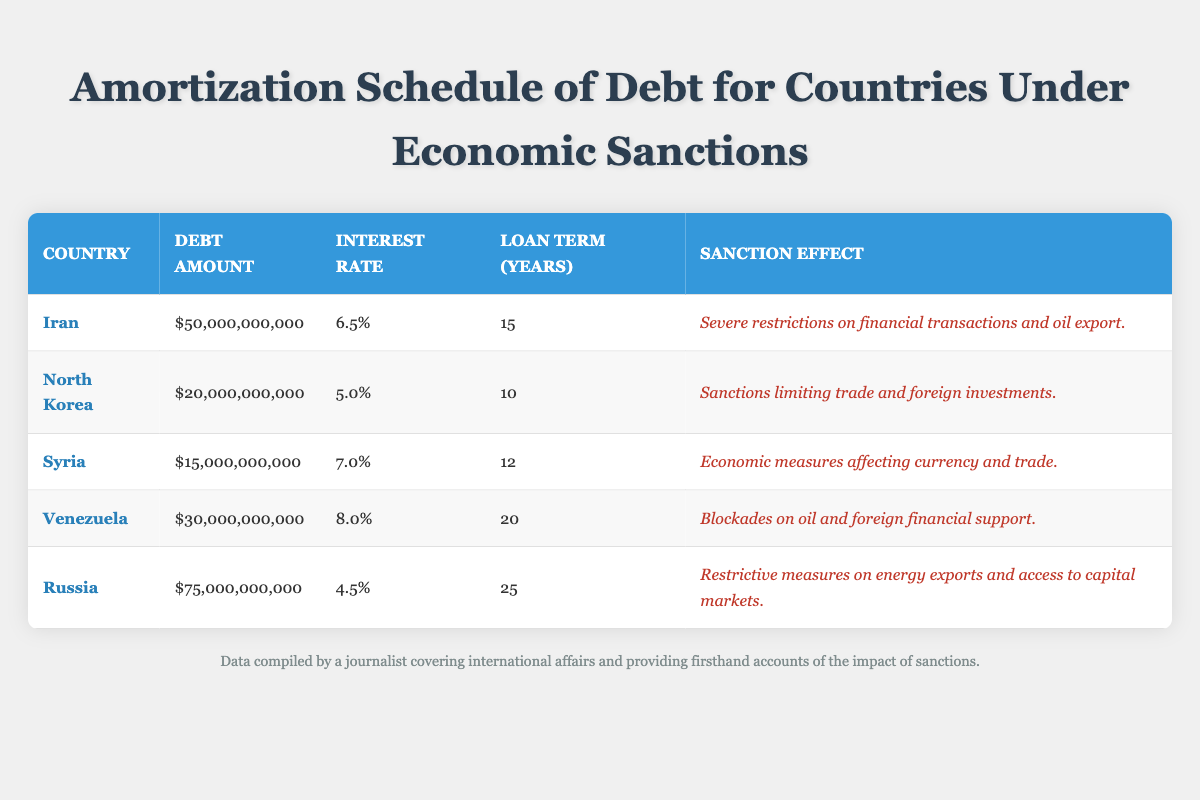What is the debt amount for Syria? The table lists Syria with a debt amount of $15,000,000,000. This can be seen directly in the row corresponding to Syria.
Answer: $15,000,000,000 Which country has the highest interest rate on its debt? By reviewing the interest rates listed in the table, we see Venezuela has the highest interest rate at 8.0%. This is the maximum value present in the interest rate column.
Answer: Venezuela What is the combined debt amount of Iran and North Korea? To find the combined debt amount, we add the debt amounts of Iran ($50,000,000,000) and North Korea ($20,000,000,000). The calculation is $50,000,000,000 + $20,000,000,000 = $70,000,000,000.
Answer: $70,000,000,000 Is it true that Russia's loan term is longer than North Korea's? By comparing the loan terms in the table, Russia's loan term is 25 years and North Korea's is 10 years. Since 25 is greater than 10, the statement is true.
Answer: Yes What is the average interest rate of the listed countries? To calculate the average interest rate, add all individual interest rates: 6.5 + 5.0 + 7.0 + 8.0 + 4.5 = 31.0. Then divide by the number of countries, which is 5: 31.0 / 5 = 6.2.
Answer: 6.2% How many countries have sanctions that affect trade? Looking at the sanction effects, we see that North Korea, Syria, and Venezuela's sanctions specifically mention trade restrictions. Counting these gives us 3 countries that are affected in this way.
Answer: 3 What is the difference in debt amount between the country with the highest and lowest debt? The country with the highest debt is Russia at $75,000,000,000 and the lowest is North Korea at $20,000,000,000. The difference is calculated as $75,000,000,000 - $20,000,000,000 = $55,000,000,000.
Answer: $55,000,000,000 Which country has the longest loan term and what is that term? Reviewing the loan terms, Russia has the longest loan term of 25 years, indicated in the respective row for Russia in the table.
Answer: 25 years Did any of the countries listed have an interest rate below 5.0%? By examining the interest rates, we find that the lowest is 4.5% (Russia), which is below 5.0%. Thus, the answer to this question is true.
Answer: Yes 